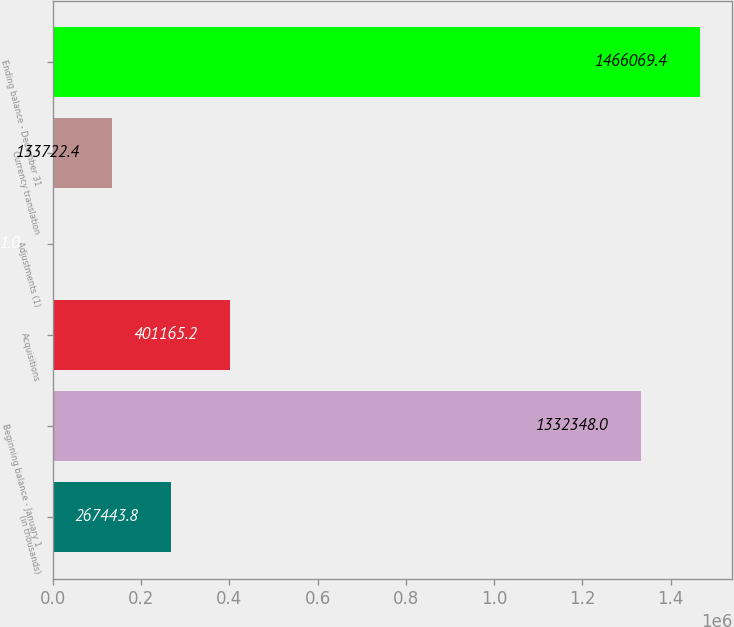Convert chart to OTSL. <chart><loc_0><loc_0><loc_500><loc_500><bar_chart><fcel>(in thousands)<fcel>Beginning balance - January 1<fcel>Acquisitions<fcel>Adjustments (1)<fcel>Currency translation<fcel>Ending balance - December 31<nl><fcel>267444<fcel>1.33235e+06<fcel>401165<fcel>1<fcel>133722<fcel>1.46607e+06<nl></chart> 